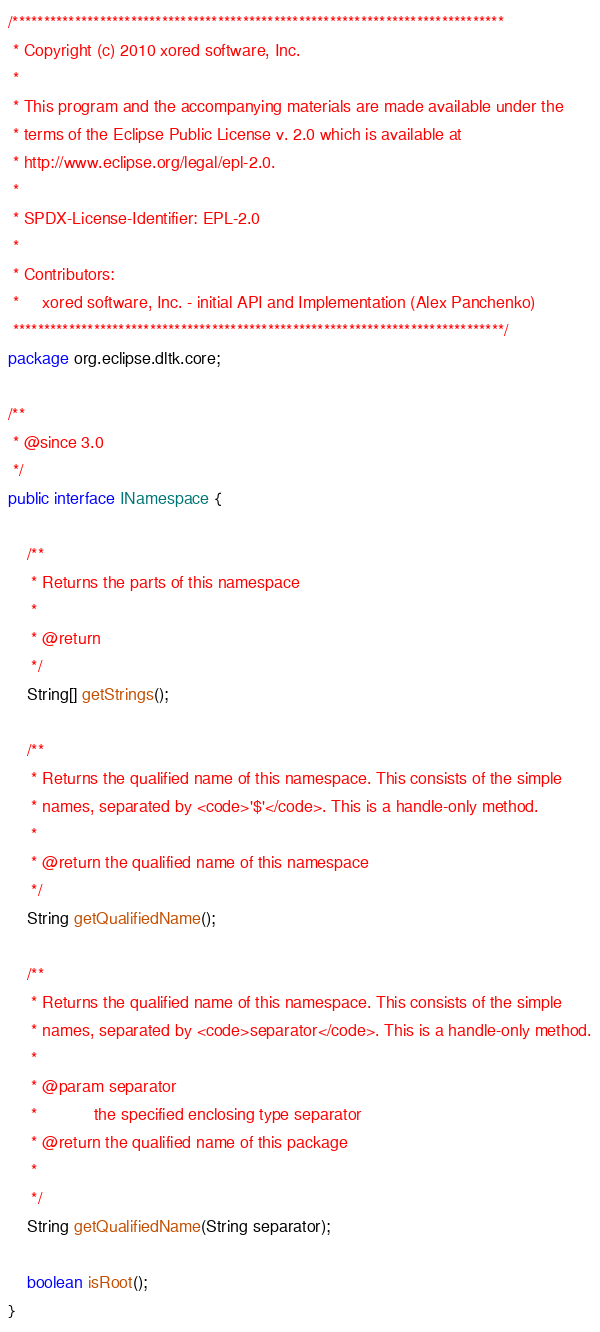Convert code to text. <code><loc_0><loc_0><loc_500><loc_500><_Java_>/*******************************************************************************
 * Copyright (c) 2010 xored software, Inc.
 *
 * This program and the accompanying materials are made available under the
 * terms of the Eclipse Public License v. 2.0 which is available at
 * http://www.eclipse.org/legal/epl-2.0.
 * 
 * SPDX-License-Identifier: EPL-2.0
 *
 * Contributors:
 *     xored software, Inc. - initial API and Implementation (Alex Panchenko)
 *******************************************************************************/
package org.eclipse.dltk.core;

/**
 * @since 3.0
 */
public interface INamespace {

	/**
	 * Returns the parts of this namespace
	 * 
	 * @return
	 */
	String[] getStrings();

	/**
	 * Returns the qualified name of this namespace. This consists of the simple
	 * names, separated by <code>'$'</code>. This is a handle-only method.
	 * 
	 * @return the qualified name of this namespace
	 */
	String getQualifiedName();

	/**
	 * Returns the qualified name of this namespace. This consists of the simple
	 * names, separated by <code>separator</code>. This is a handle-only method.
	 * 
	 * @param separator
	 *            the specified enclosing type separator
	 * @return the qualified name of this package
	 * 
	 */
	String getQualifiedName(String separator);

	boolean isRoot();
}
</code> 